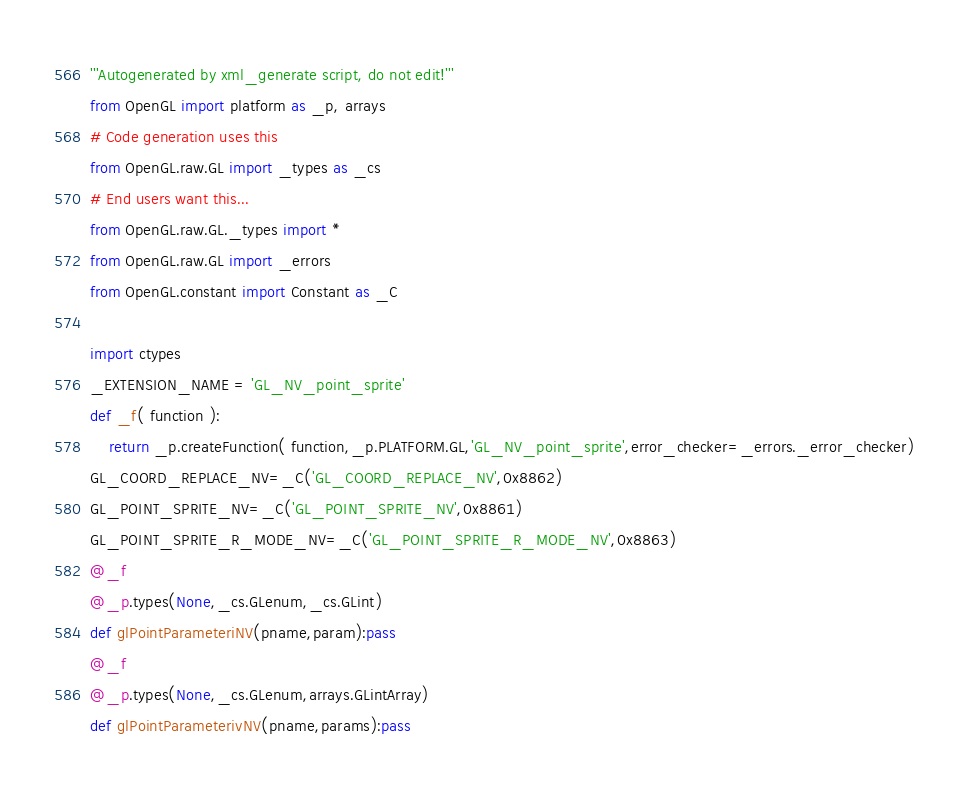Convert code to text. <code><loc_0><loc_0><loc_500><loc_500><_Python_>'''Autogenerated by xml_generate script, do not edit!'''
from OpenGL import platform as _p, arrays
# Code generation uses this
from OpenGL.raw.GL import _types as _cs
# End users want this...
from OpenGL.raw.GL._types import *
from OpenGL.raw.GL import _errors
from OpenGL.constant import Constant as _C

import ctypes
_EXTENSION_NAME = 'GL_NV_point_sprite'
def _f( function ):
    return _p.createFunction( function,_p.PLATFORM.GL,'GL_NV_point_sprite',error_checker=_errors._error_checker)
GL_COORD_REPLACE_NV=_C('GL_COORD_REPLACE_NV',0x8862)
GL_POINT_SPRITE_NV=_C('GL_POINT_SPRITE_NV',0x8861)
GL_POINT_SPRITE_R_MODE_NV=_C('GL_POINT_SPRITE_R_MODE_NV',0x8863)
@_f
@_p.types(None,_cs.GLenum,_cs.GLint)
def glPointParameteriNV(pname,param):pass
@_f
@_p.types(None,_cs.GLenum,arrays.GLintArray)
def glPointParameterivNV(pname,params):pass
</code> 